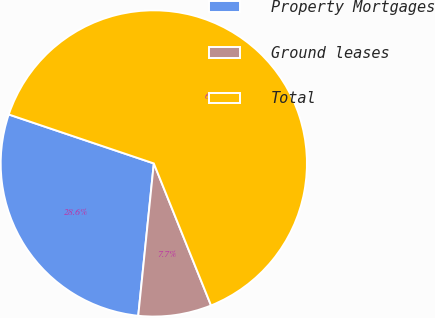Convert chart. <chart><loc_0><loc_0><loc_500><loc_500><pie_chart><fcel>Property Mortgages<fcel>Ground leases<fcel>Total<nl><fcel>28.56%<fcel>7.72%<fcel>63.73%<nl></chart> 